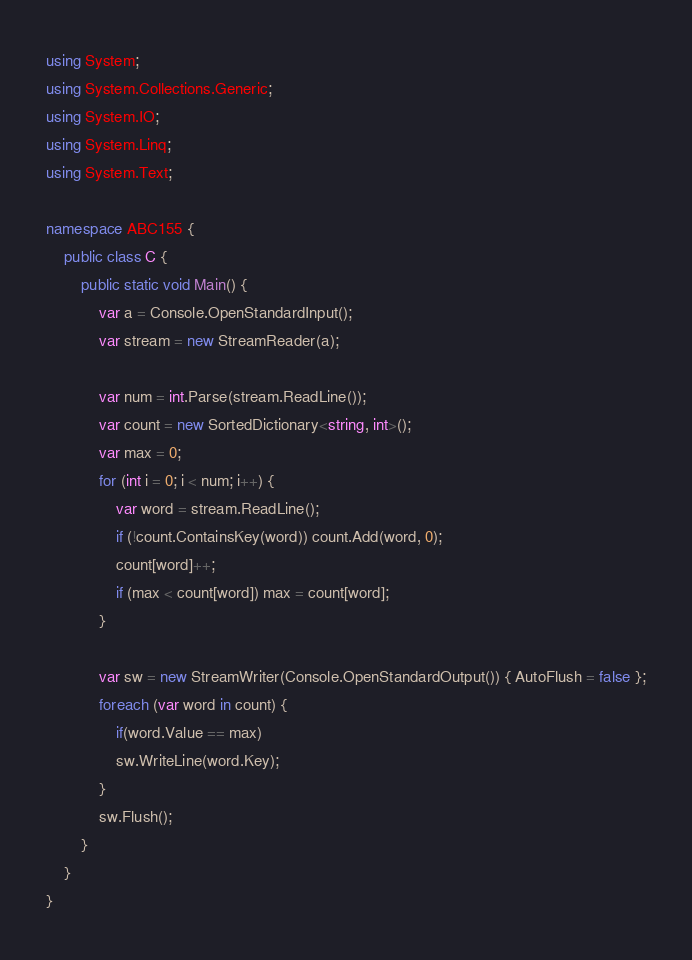<code> <loc_0><loc_0><loc_500><loc_500><_C#_>using System;
using System.Collections.Generic;
using System.IO;
using System.Linq;
using System.Text;

namespace ABC155 {
    public class C {
        public static void Main() {
            var a = Console.OpenStandardInput();
            var stream = new StreamReader(a);

            var num = int.Parse(stream.ReadLine());
            var count = new SortedDictionary<string, int>();
            var max = 0;
            for (int i = 0; i < num; i++) {
                var word = stream.ReadLine();
                if (!count.ContainsKey(word)) count.Add(word, 0);
                count[word]++;
                if (max < count[word]) max = count[word];
            }

            var sw = new StreamWriter(Console.OpenStandardOutput()) { AutoFlush = false };
            foreach (var word in count) {
                if(word.Value == max)
                sw.WriteLine(word.Key);
            }
            sw.Flush();
        }
    }
}</code> 